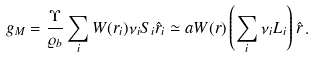<formula> <loc_0><loc_0><loc_500><loc_500>g _ { M } = \frac { \Upsilon } { \varrho _ { b } } \sum _ { i } W ( r _ { i } ) \nu _ { i } S _ { i } \hat { r } _ { i } \simeq a W ( r ) \left ( \sum _ { i } \nu _ { i } L _ { i } \right ) \hat { r } \, .</formula> 